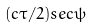<formula> <loc_0><loc_0><loc_500><loc_500>( c \tau / 2 ) s e c \psi</formula> 